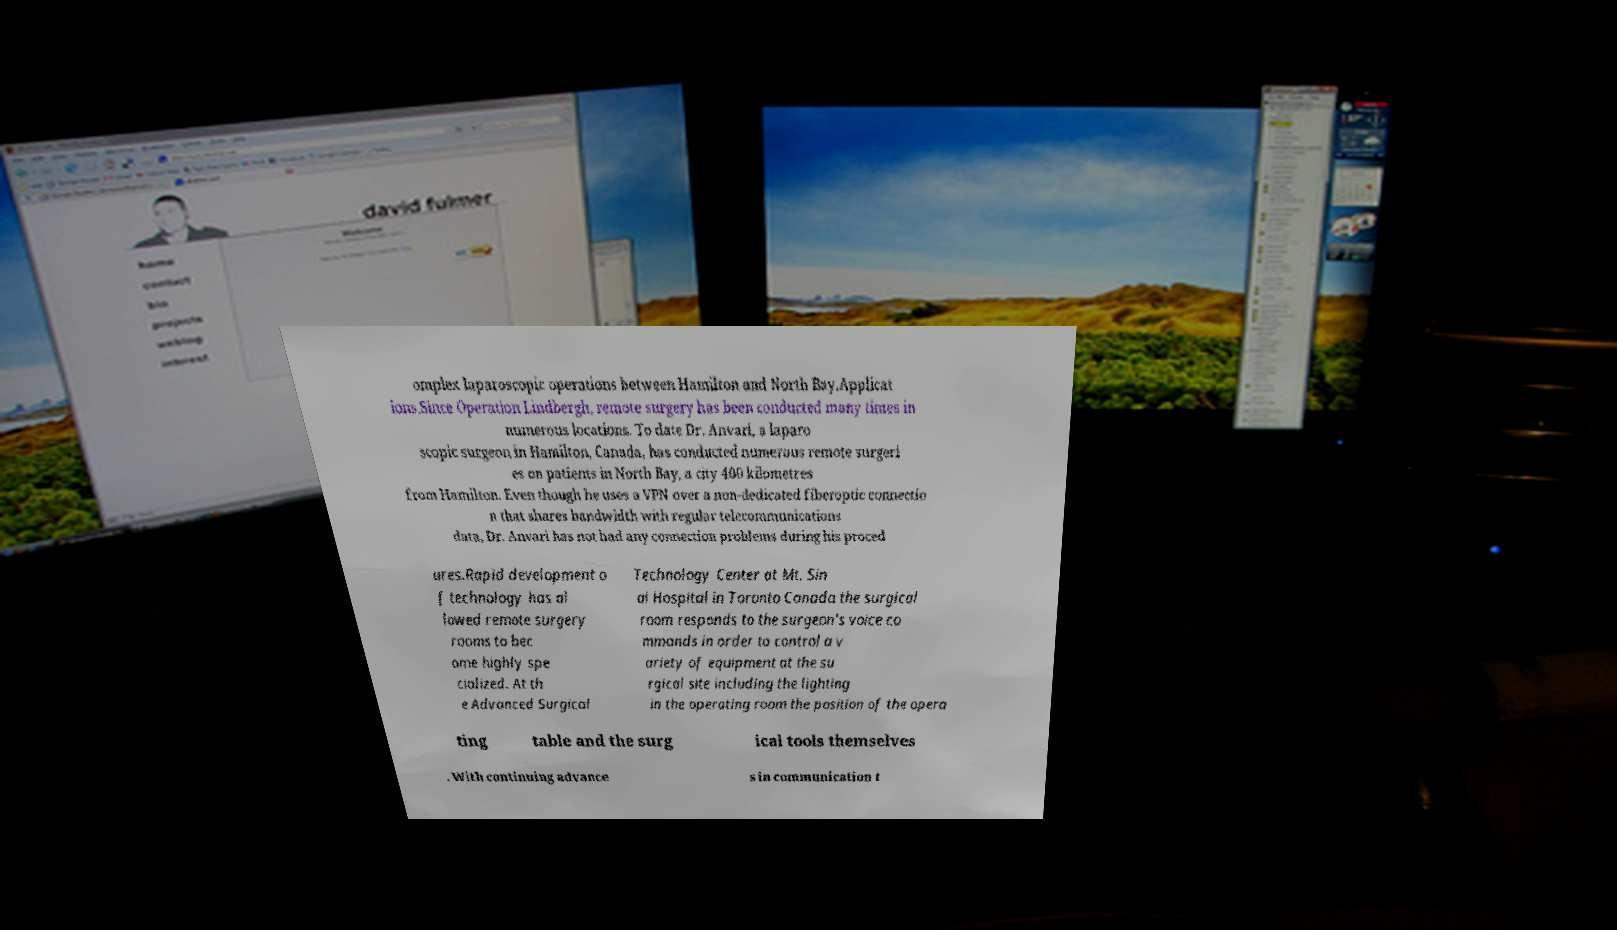I need the written content from this picture converted into text. Can you do that? omplex laparoscopic operations between Hamilton and North Bay.Applicat ions.Since Operation Lindbergh, remote surgery has been conducted many times in numerous locations. To date Dr. Anvari, a laparo scopic surgeon in Hamilton, Canada, has conducted numerous remote surgeri es on patients in North Bay, a city 400 kilometres from Hamilton. Even though he uses a VPN over a non-dedicated fiberoptic connectio n that shares bandwidth with regular telecommunications data, Dr. Anvari has not had any connection problems during his proced ures.Rapid development o f technology has al lowed remote surgery rooms to bec ome highly spe cialized. At th e Advanced Surgical Technology Center at Mt. Sin ai Hospital in Toronto Canada the surgical room responds to the surgeon's voice co mmands in order to control a v ariety of equipment at the su rgical site including the lighting in the operating room the position of the opera ting table and the surg ical tools themselves . With continuing advance s in communication t 